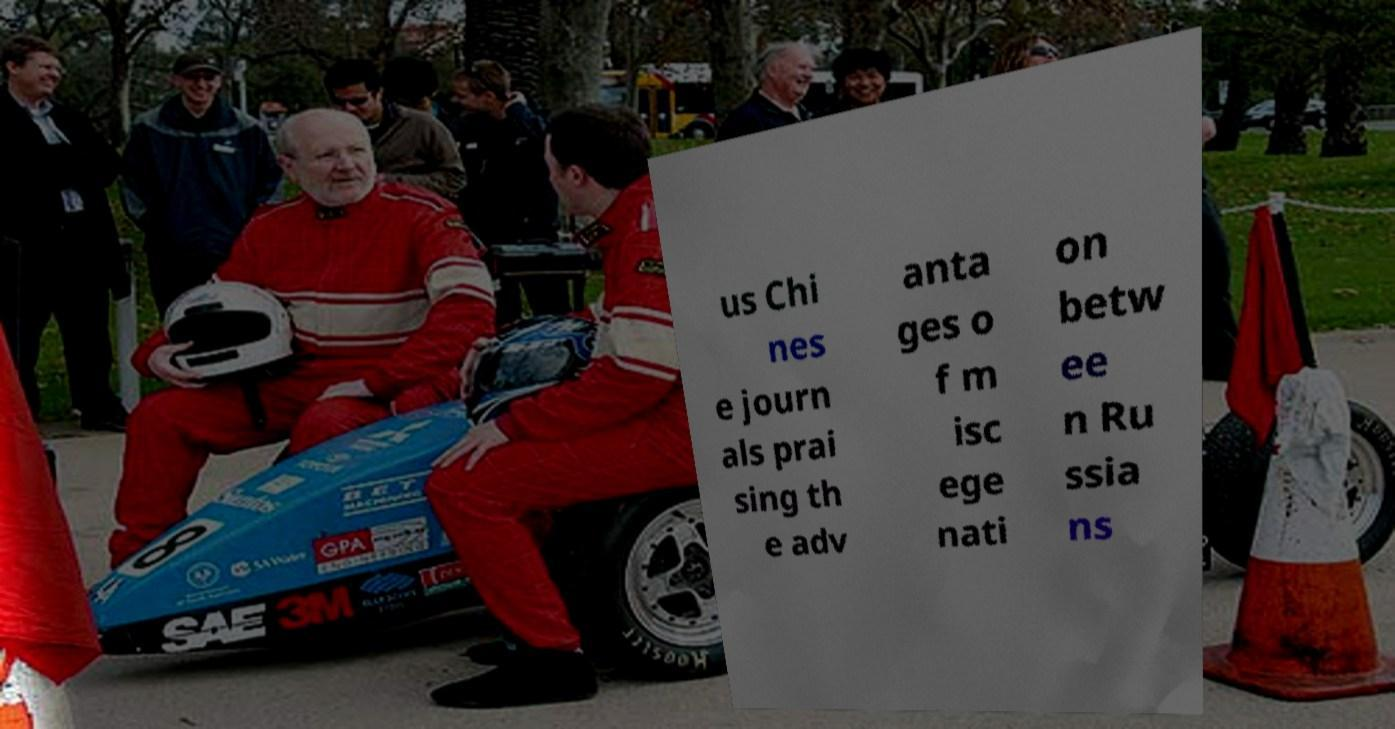I need the written content from this picture converted into text. Can you do that? us Chi nes e journ als prai sing th e adv anta ges o f m isc ege nati on betw ee n Ru ssia ns 